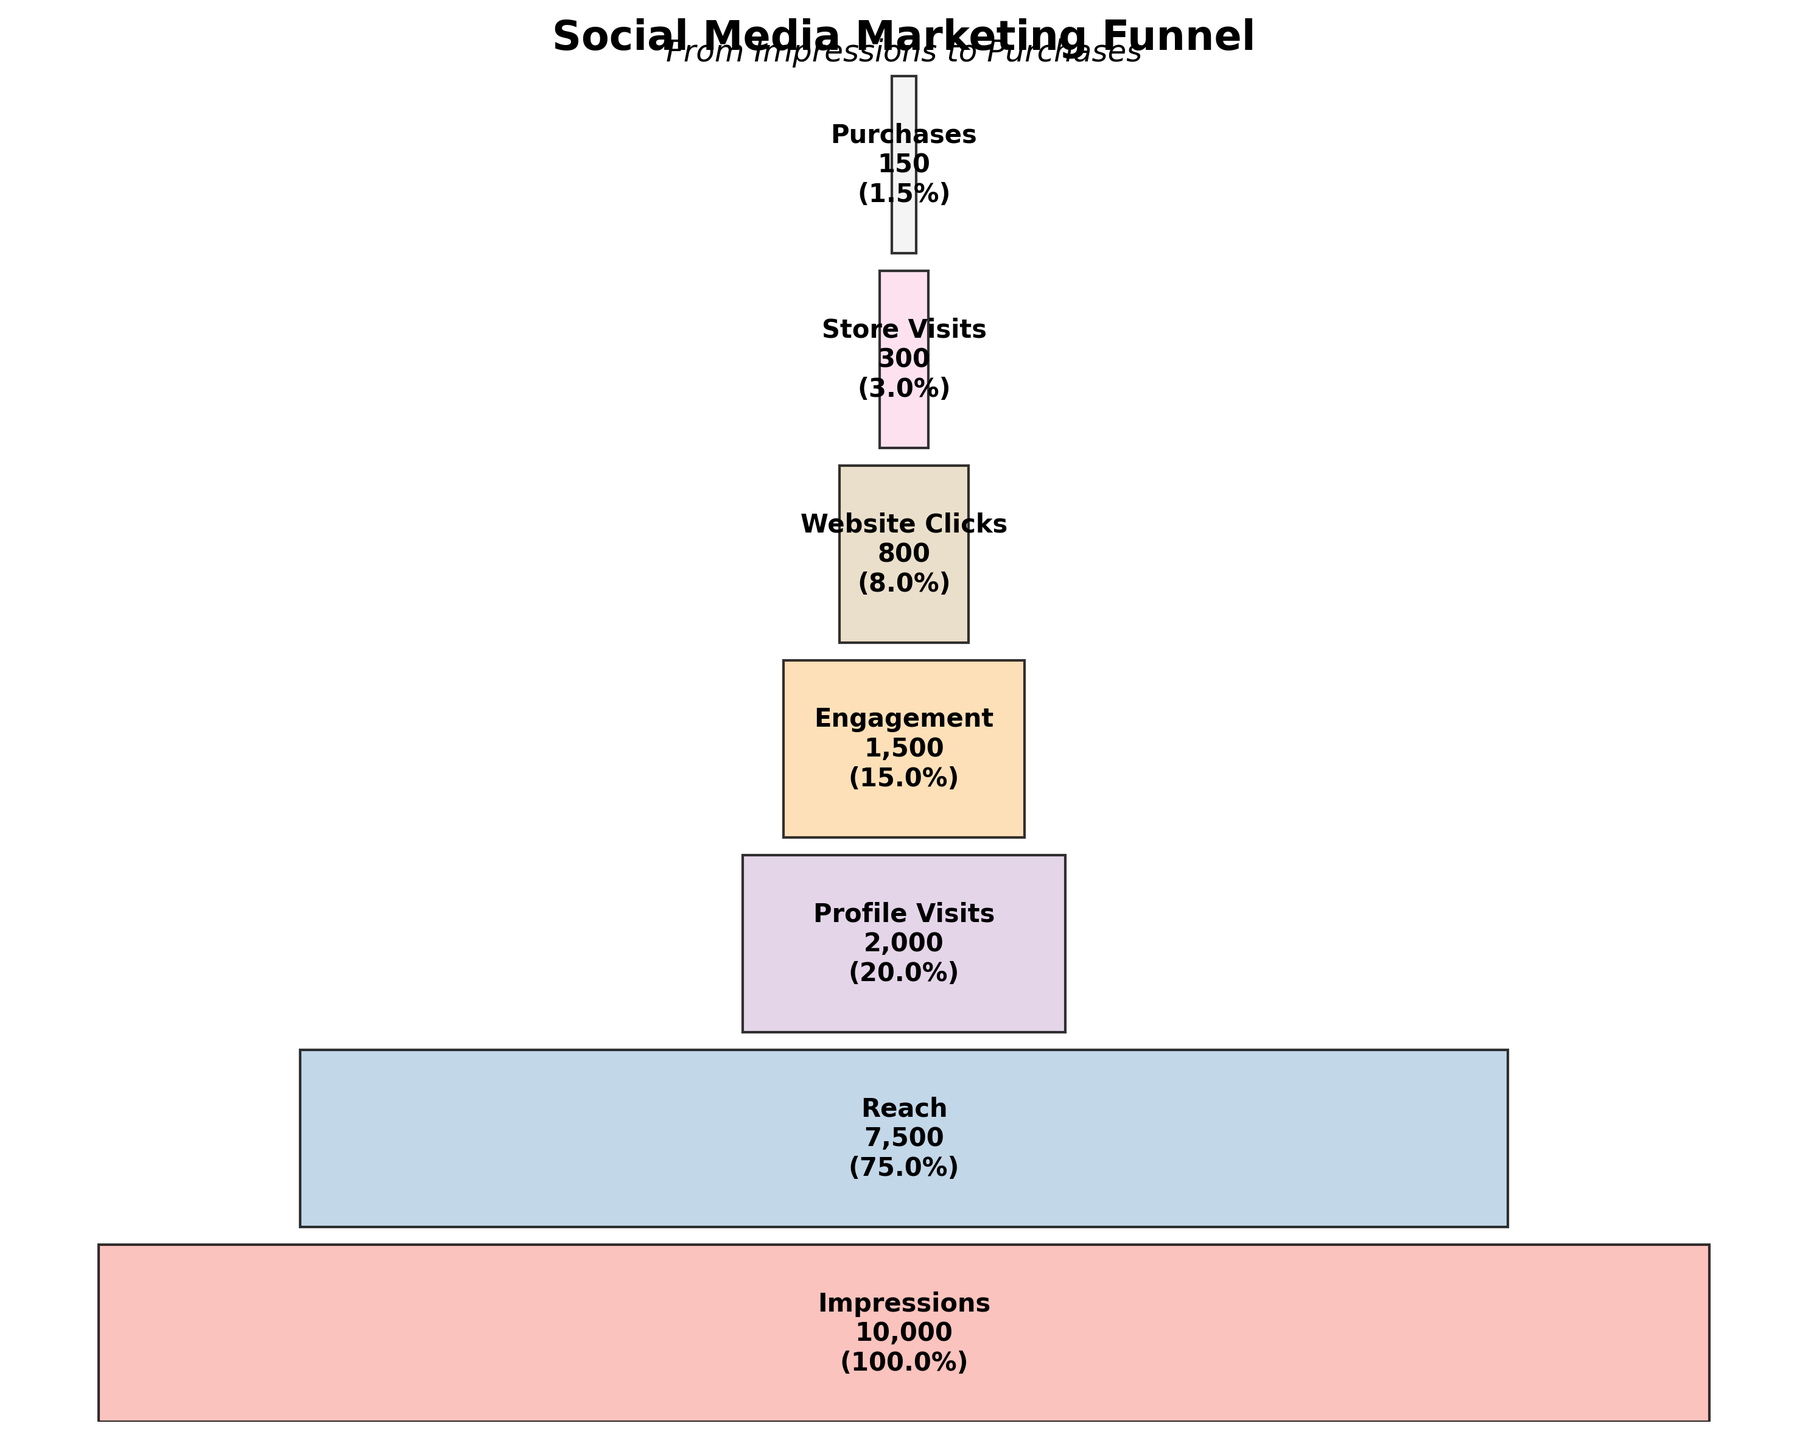What is the title of the funnel chart? The title is typically found at the top of the funnel chart and provides an overview of what the chart represents. The chart title helps in understanding the main focus of the visual representation.
Answer: Social Media Marketing Funnel How many stages are there in the funnel chart? By counting the different segments of the funnel, each labeled with a stage name, we can determine the number of stages.
Answer: 7 Which stage has the highest count? The count for each stage is displayed within the corresponding segment. The segment with the largest count indicates the highest count.
Answer: Impressions What percentage of the total impressions resulted in purchases? To determine the percentage, divide the Purchases count by the Impressions count and multiply by 100. The counts are 150 for Purchases and 10,000 for Impressions, so (150 / 10,000) * 100 = 1.5%.
Answer: 1.5% How much is the decrease in count from Impressions to Reach? Subtract the count for Reach from the count for Impressions to find the decrease. The counts are 10,000 for Impressions and 7,500 for Reach, so 10,000 - 7,500 = 2,500.
Answer: 2,500 How many profile visits result from the reached audience? From the funnel chart, find the counts for Profile Visits and Reach. The counts are 2,000 for Profile Visits and 7,500 for Reach.
Answer: 2,000 What is the least represented stage in the funnel? The stage with the smallest count is indicated within the funnel chart.
Answer: Purchases How many more website clicks are there than store visits? Subtract the count for Store Visits from the count for Website Clicks. The counts are 800 for Website Clicks and 300 for Store Visits, so 800 - 300 = 500.
Answer: 500 How does the number of engagements compare to website clicks? Look at the counts for Engagements and Website Clicks. The counts are 1,500 for Engagements and 800 for Website Clicks, so there are more engagements than website clicks.
Answer: More engagements What is the average percentage decrease per stage from Impressions to Purchases? Calculate the percentage decrease for each stage transition, sum them up, and then divide by the number of transitions. The stages are: Impressions to Reach, Reach to Profile Visits, Profile Visits to Engagement, Engagement to Website Clicks, Website Clicks to Store Visits, Store Visits to Purchases.
Percentage decreases: (1 - 7500/10000) * 100 + (1 - 2000/7500) * 100 + (1 - 1500/2000) * 100 + (1 - 800/1500) * 100 + (1 - 300/800) * 100 + (1 - 150/300) * 100, which is 25% + 73.33% + 25% + 46.67% + 62.5% + 50%. Average = (25 + 73.33 + 25 + 46.67 + 62.5 + 50) / 6, approximately 47.1%.
Answer: 47.1% 